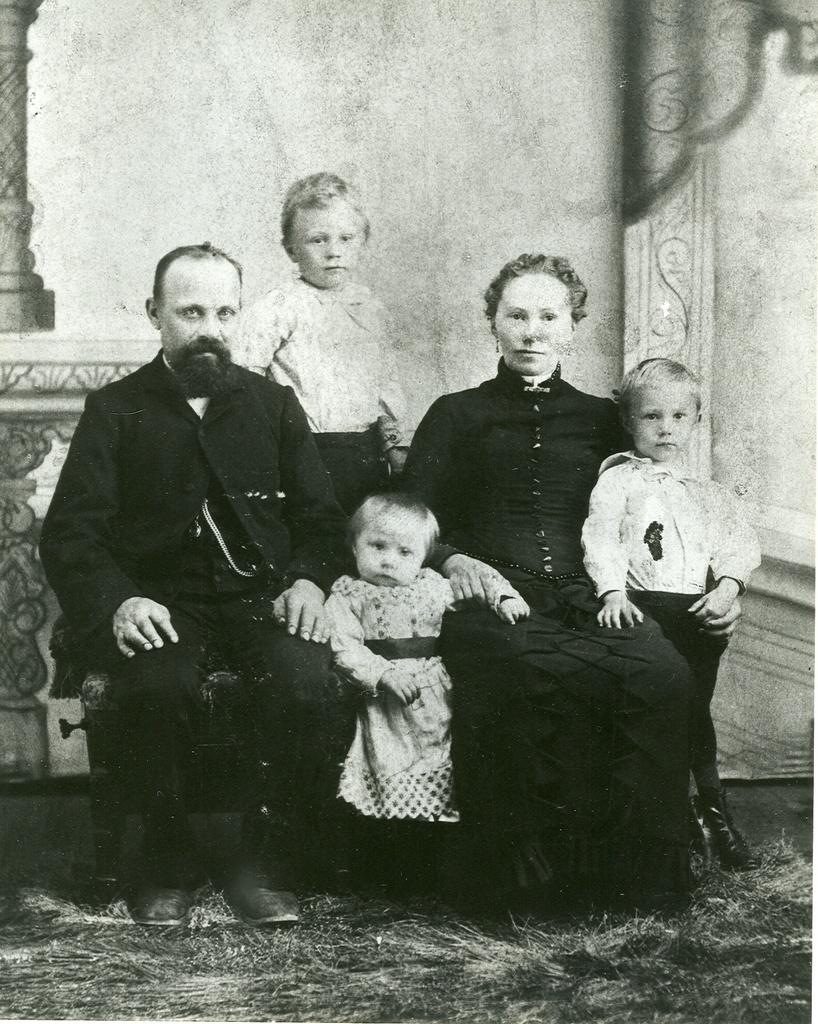What is the color scheme of the image? The image is black and white. What can be seen in the image? There are people in the image. What is visible in the background of the image? There is a wall in the background of the image. What is located on the left side of the image? There is a pillar on the left side of the image. How many robins are perched on the pillar in the image? There are no robins present in the image; it only features people and a wall in the background. 